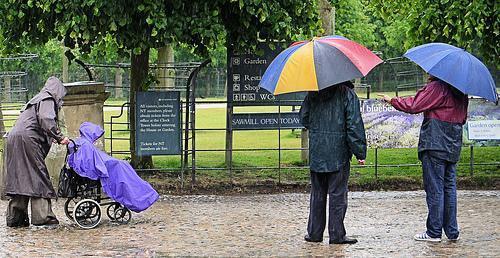How many umbrellas are there?
Give a very brief answer. 2. 